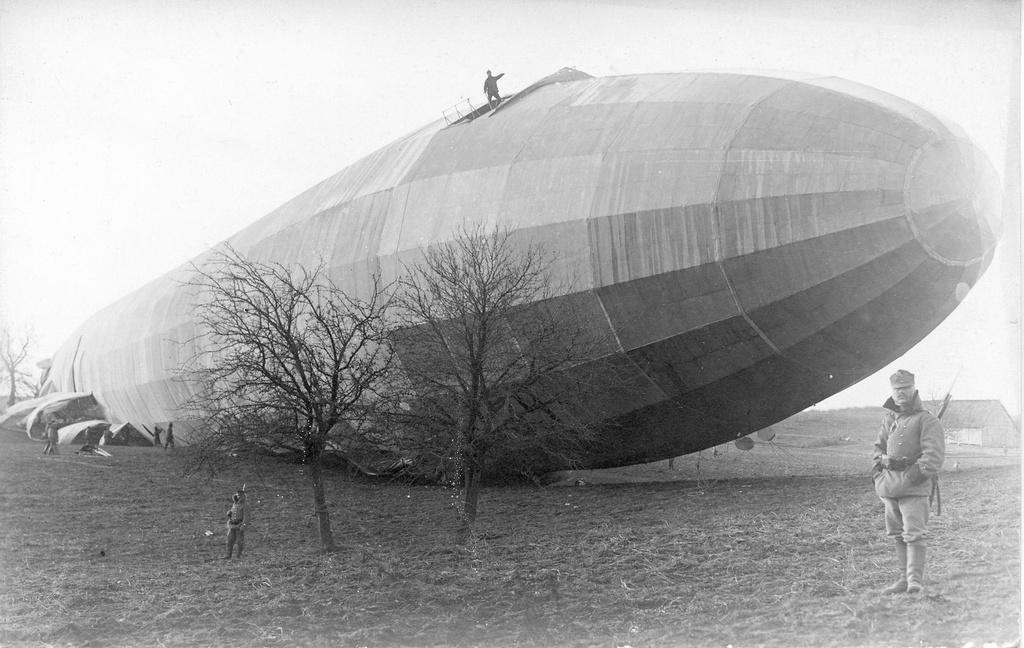Can you describe this image briefly? In this image there are a few people standing, behind them there are trees with dry branches and there is an airship wreck, on top of it there is a person standing. 